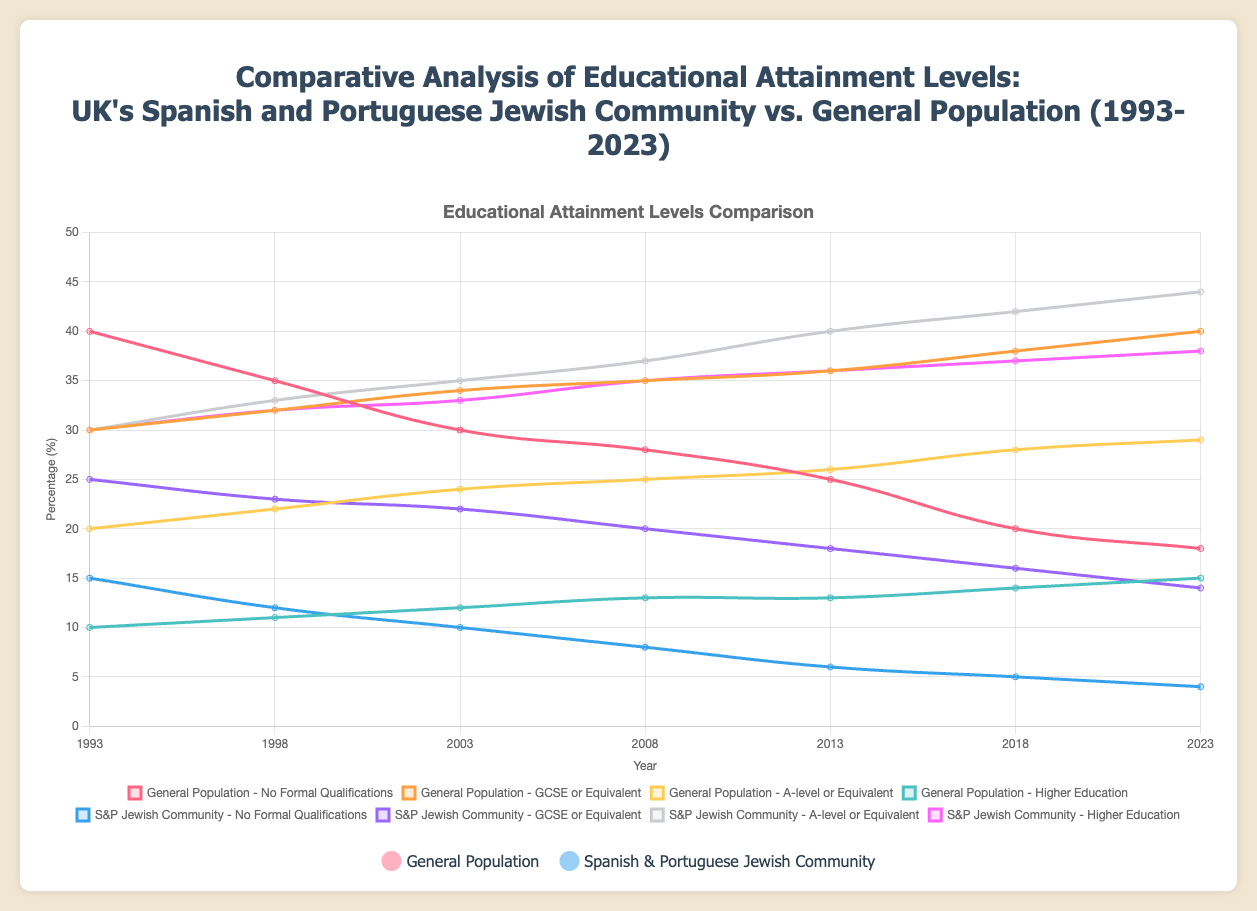What is the trend in the percentage of people with no formal qualifications in the Spanish and Portuguese Jewish Community from 1993 to 2023? We can observe the line representing the percentage of people with no formal qualifications in the Spanish and Portuguese Jewish Community from 1993 to 2023. It starts at 15% in 1993 and consistently decreases over time, ending at 4% in 2023.
Answer: Decreasing In which year did the Spanish and Portuguese Jewish Community have the highest percentage of individuals with A-level or equivalent qualifications, and what was that percentage? By checking the graph for the highest peak in the line representing A-level or equivalent qualifications for the Spanish and Portuguese Jewish Community, we find it peaked in 2023 at 44%.
Answer: 2023, 44% How does the percentage of the general population with higher education in 2023 compare to that of the Spanish and Portuguese Jewish Community in the same year? We look at the percentages in the graph for higher education in 2023. The general population has 15%, and the Spanish and Portuguese Jewish Community has 38%. The latter is higher.
Answer: The Spanish and Portuguese Jewish Community has a higher percentage What is the average percentage of individuals with GCSE or equivalent qualifications in the general population over the 30 years? To find the average, add the percentages for each year: (30 + 32 + 34 + 35 + 36 + 38 + 40) = 245. Then, divide by the number of data points: 245 / 7 ≈ 35.
Answer: 35% What visual differences can you observe in the trends of higher education between the general population and the Spanish and Portuguese Jewish Community? Observing the graph, the trend line for the general population's higher education remains relatively flat, slightly increasing from 10% to 15%. In contrast, the Spanish and Portuguese Jewish Community shows a steep increase from 30% to 38%, indicating a significant rise.
Answer: The Spanish and Portuguese Jewish Community shows a steeper increase Which group had a lower percentage of people with no formal qualifications in 1993, and by how much? In 1993, the general population has 40% without formal qualifications, whereas the Spanish and Portuguese Jewish Community has 15%. The difference is 40 - 15 = 25%.
Answer: Spanish and Portuguese Jewish Community, by 25% Between 2013 and 2018, did the general population or the Spanish and Portuguese Jewish Community show a greater change in the percentage of individuals with A-level or equivalent qualifications? The percentage of individuals with A-level or equivalent qualifications in the general population increased from 26% to 28%, a change of 2%. For the Spanish and Portuguese Jewish Community, it increased from 40% to 42%, a change of 2%. Both groups showed the same change of 2%.
Answer: Both showed the same change of 2% How has the gap between the general population and the Spanish and Portuguese Jewish Community in higher education changed from 1993 to 2023? In 1993, the gap was 30% - 10% = 20%. In 2023, the gap was 38% - 15% = 23%. The gap increased by 3%.
Answer: Increased by 3% 